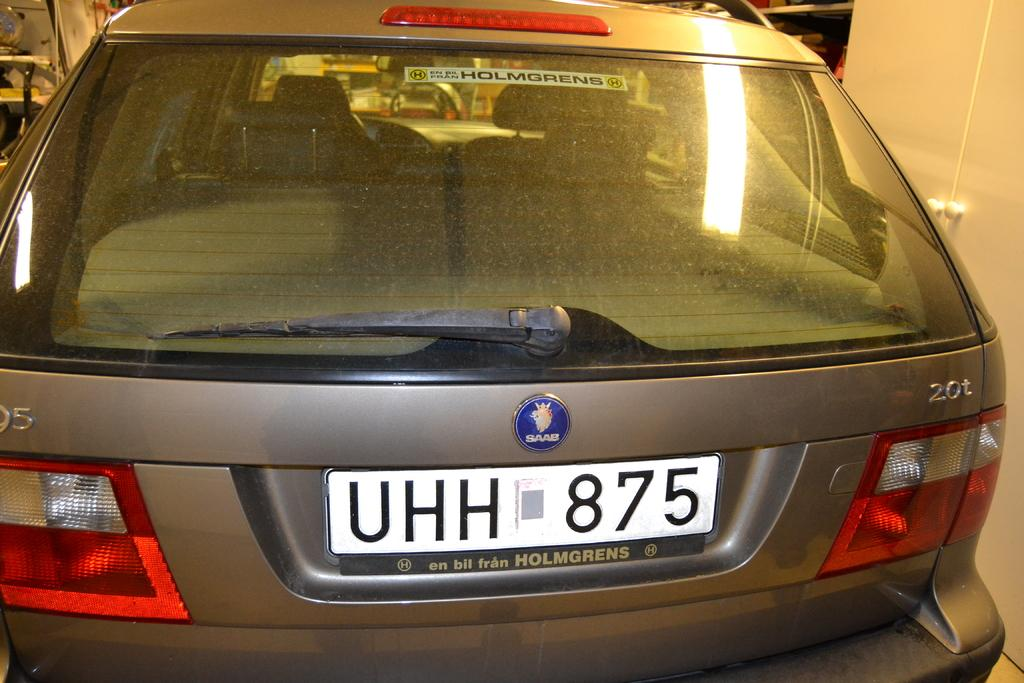<image>
Offer a succinct explanation of the picture presented. A SAAB car with the license plate UHH 875. 